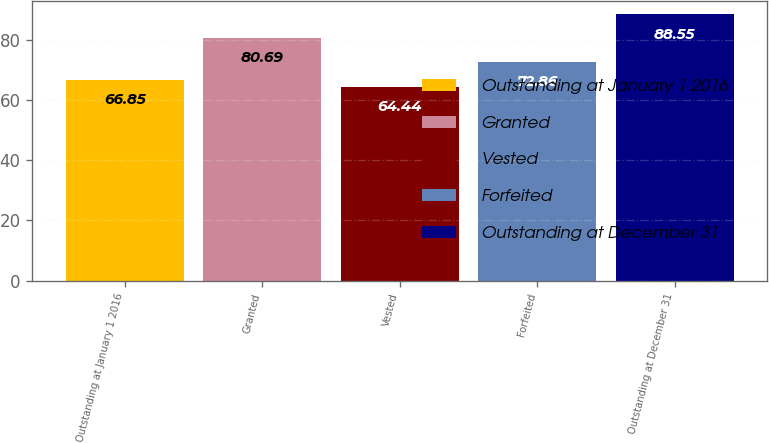Convert chart. <chart><loc_0><loc_0><loc_500><loc_500><bar_chart><fcel>Outstanding at January 1 2016<fcel>Granted<fcel>Vested<fcel>Forfeited<fcel>Outstanding at December 31<nl><fcel>66.85<fcel>80.69<fcel>64.44<fcel>72.86<fcel>88.55<nl></chart> 